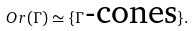Convert formula to latex. <formula><loc_0><loc_0><loc_500><loc_500>O r ( \Gamma ) \simeq \{ \Gamma \text {-cones} \} .</formula> 